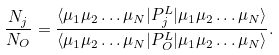Convert formula to latex. <formula><loc_0><loc_0><loc_500><loc_500>\frac { N _ { j } } { N _ { O } } = \frac { \langle \mu _ { 1 } \mu _ { 2 } \dots \mu _ { N } | P _ { j } ^ { L } | \mu _ { 1 } \mu _ { 2 } \dots \mu _ { N } \rangle } { \langle \mu _ { 1 } \mu _ { 2 } \dots \mu _ { N } | P _ { O } ^ { L } | \mu _ { 1 } \mu _ { 2 } \dots \mu _ { N } \rangle } .</formula> 